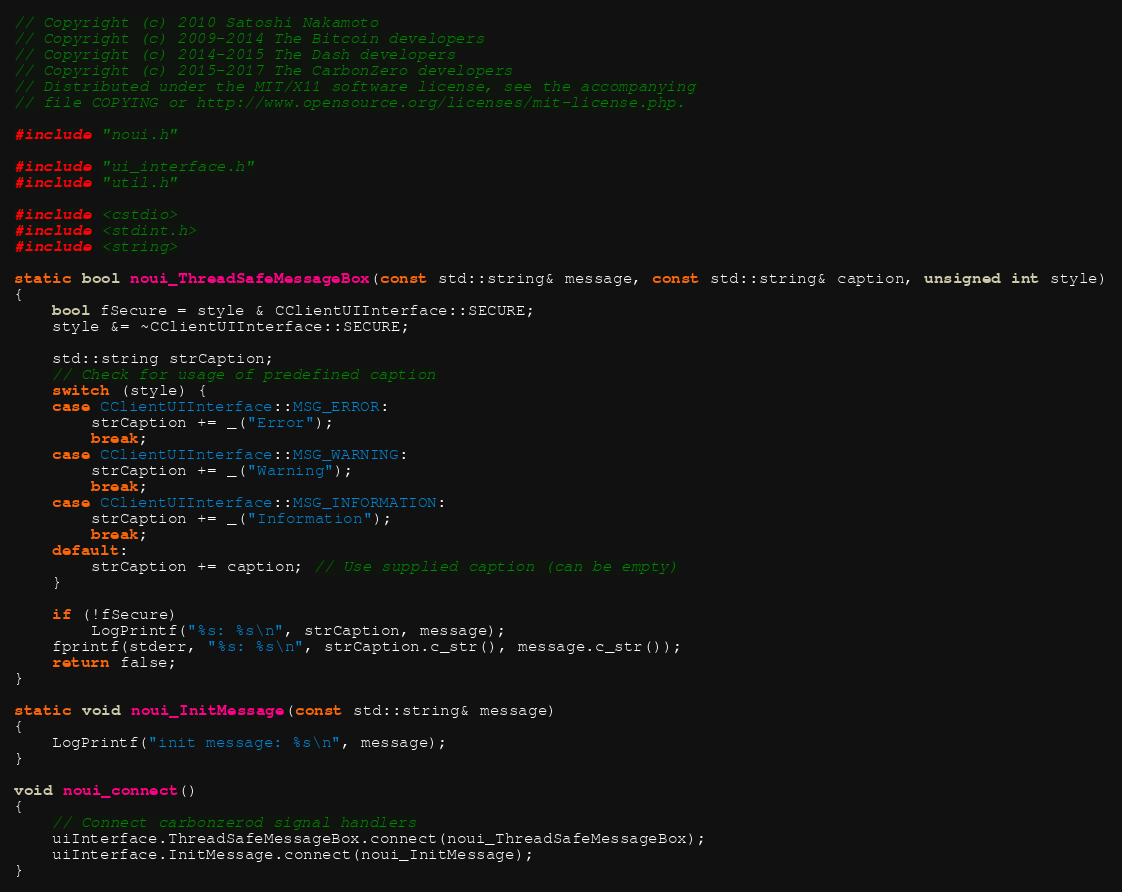<code> <loc_0><loc_0><loc_500><loc_500><_C++_>// Copyright (c) 2010 Satoshi Nakamoto
// Copyright (c) 2009-2014 The Bitcoin developers
// Copyright (c) 2014-2015 The Dash developers
// Copyright (c) 2015-2017 The CarbonZero developers
// Distributed under the MIT/X11 software license, see the accompanying
// file COPYING or http://www.opensource.org/licenses/mit-license.php.

#include "noui.h"

#include "ui_interface.h"
#include "util.h"

#include <cstdio>
#include <stdint.h>
#include <string>

static bool noui_ThreadSafeMessageBox(const std::string& message, const std::string& caption, unsigned int style)
{
    bool fSecure = style & CClientUIInterface::SECURE;
    style &= ~CClientUIInterface::SECURE;

    std::string strCaption;
    // Check for usage of predefined caption
    switch (style) {
    case CClientUIInterface::MSG_ERROR:
        strCaption += _("Error");
        break;
    case CClientUIInterface::MSG_WARNING:
        strCaption += _("Warning");
        break;
    case CClientUIInterface::MSG_INFORMATION:
        strCaption += _("Information");
        break;
    default:
        strCaption += caption; // Use supplied caption (can be empty)
    }

    if (!fSecure)
        LogPrintf("%s: %s\n", strCaption, message);
    fprintf(stderr, "%s: %s\n", strCaption.c_str(), message.c_str());
    return false;
}

static void noui_InitMessage(const std::string& message)
{
    LogPrintf("init message: %s\n", message);
}

void noui_connect()
{
    // Connect carbonzerod signal handlers
    uiInterface.ThreadSafeMessageBox.connect(noui_ThreadSafeMessageBox);
    uiInterface.InitMessage.connect(noui_InitMessage);
}
</code> 